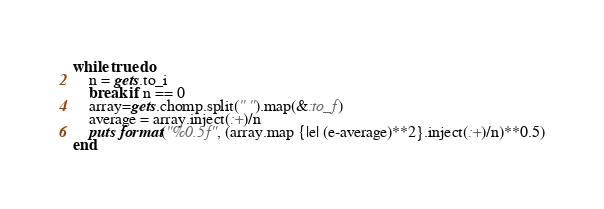<code> <loc_0><loc_0><loc_500><loc_500><_Ruby_>while true do
    n = gets.to_i
    break if n == 0
    array=gets.chomp.split(" ").map(&:to_f)
    average = array.inject(:+)/n
    puts format("%0.5f", (array.map {|e| (e-average)**2}.inject(:+)/n)**0.5)
end
</code> 